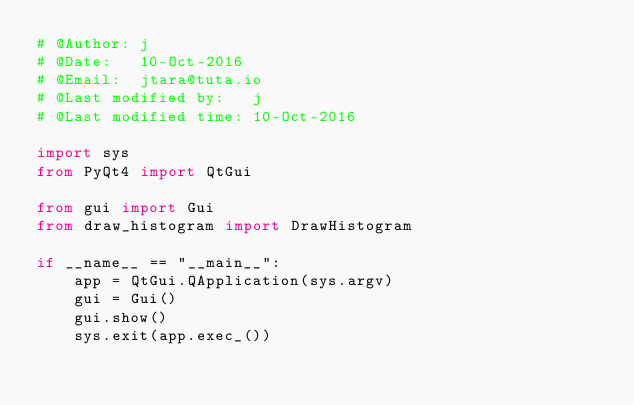<code> <loc_0><loc_0><loc_500><loc_500><_Python_># @Author: j
# @Date:   10-Oct-2016
# @Email:  jtara@tuta.io
# @Last modified by:   j
# @Last modified time: 10-Oct-2016

import sys
from PyQt4 import QtGui

from gui import Gui
from draw_histogram import DrawHistogram

if __name__ == "__main__":
    app = QtGui.QApplication(sys.argv)
    gui = Gui()
    gui.show()
    sys.exit(app.exec_())
</code> 